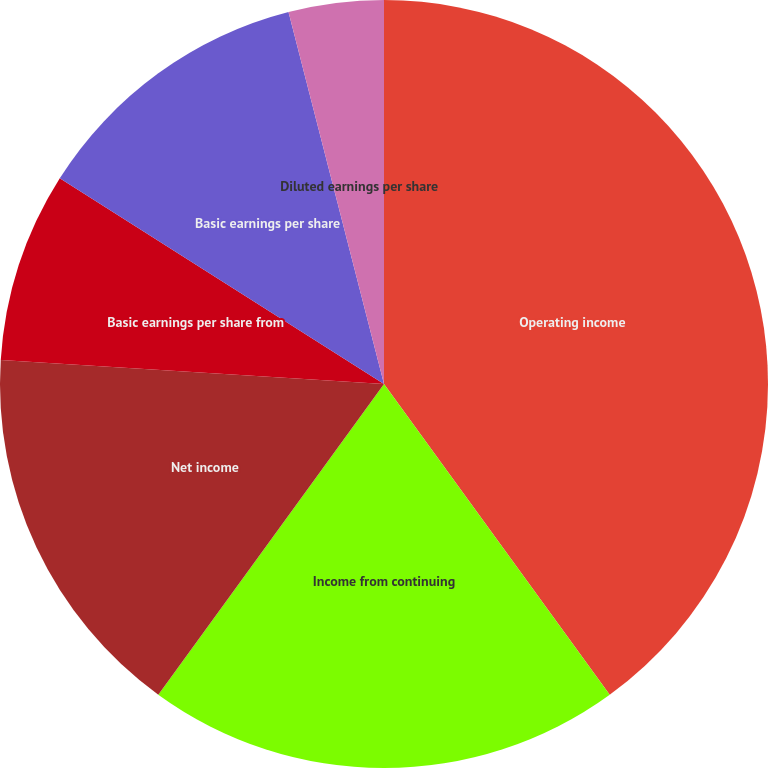Convert chart. <chart><loc_0><loc_0><loc_500><loc_500><pie_chart><fcel>Operating income<fcel>Income from continuing<fcel>Net income<fcel>Basic earnings per share from<fcel>Basic earnings per share<fcel>Diluted earnings per share<nl><fcel>40.0%<fcel>20.0%<fcel>16.0%<fcel>8.0%<fcel>12.0%<fcel>4.0%<nl></chart> 